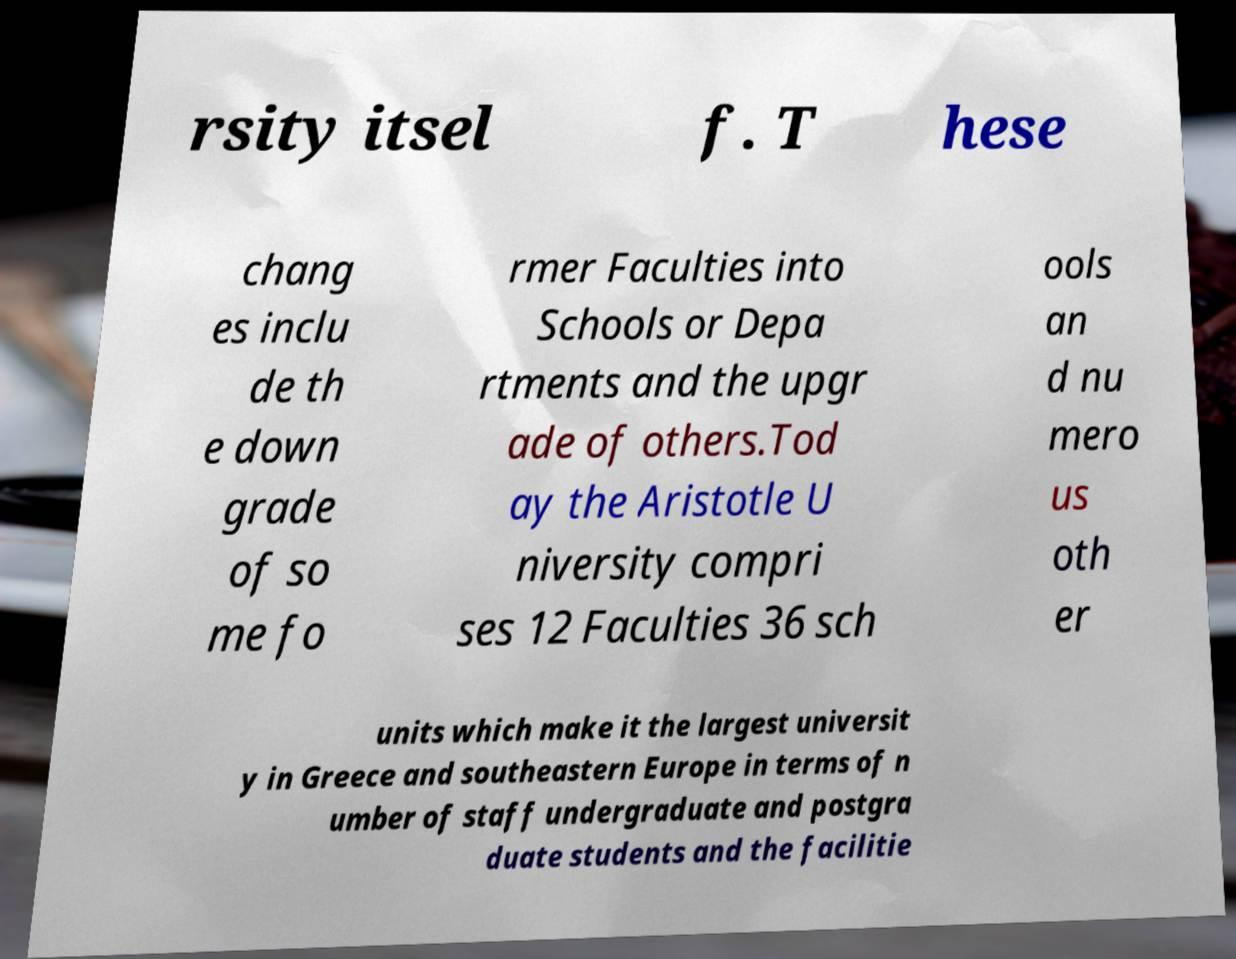For documentation purposes, I need the text within this image transcribed. Could you provide that? rsity itsel f. T hese chang es inclu de th e down grade of so me fo rmer Faculties into Schools or Depa rtments and the upgr ade of others.Tod ay the Aristotle U niversity compri ses 12 Faculties 36 sch ools an d nu mero us oth er units which make it the largest universit y in Greece and southeastern Europe in terms of n umber of staff undergraduate and postgra duate students and the facilitie 